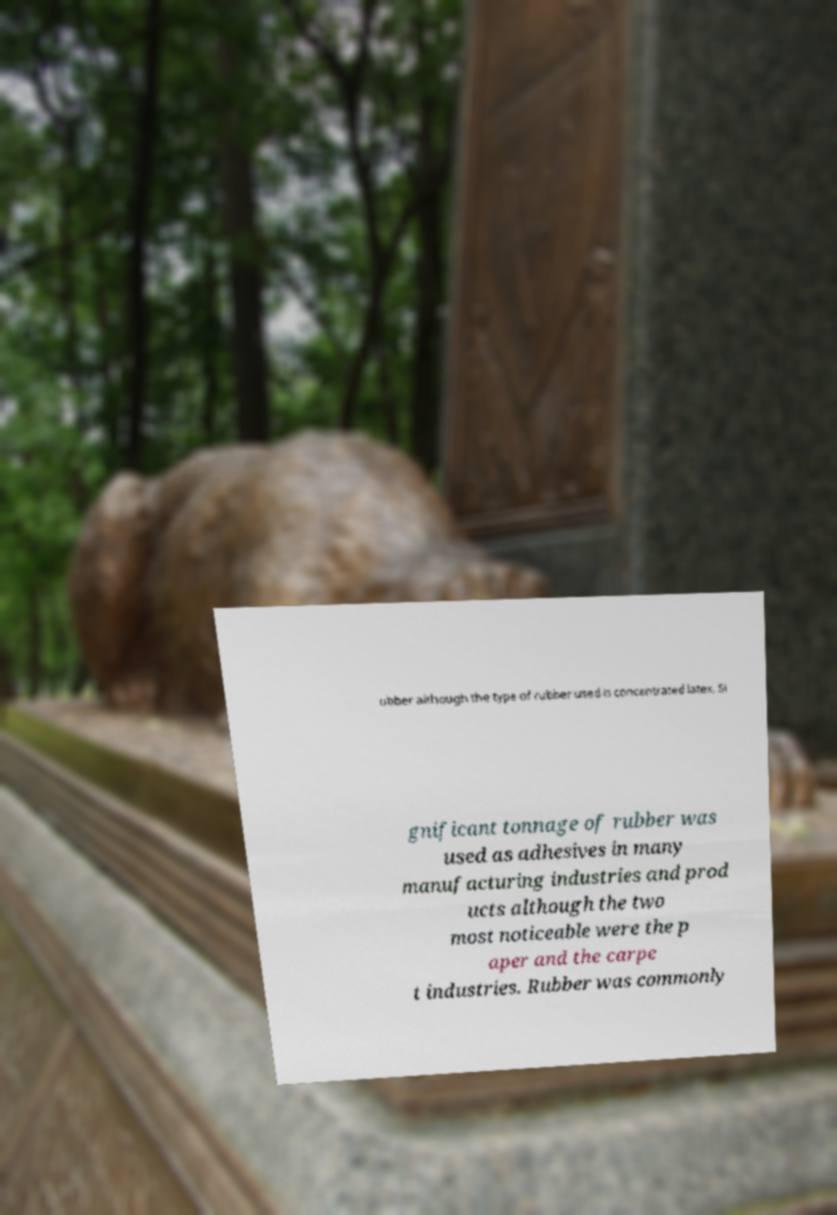There's text embedded in this image that I need extracted. Can you transcribe it verbatim? ubber although the type of rubber used is concentrated latex. Si gnificant tonnage of rubber was used as adhesives in many manufacturing industries and prod ucts although the two most noticeable were the p aper and the carpe t industries. Rubber was commonly 